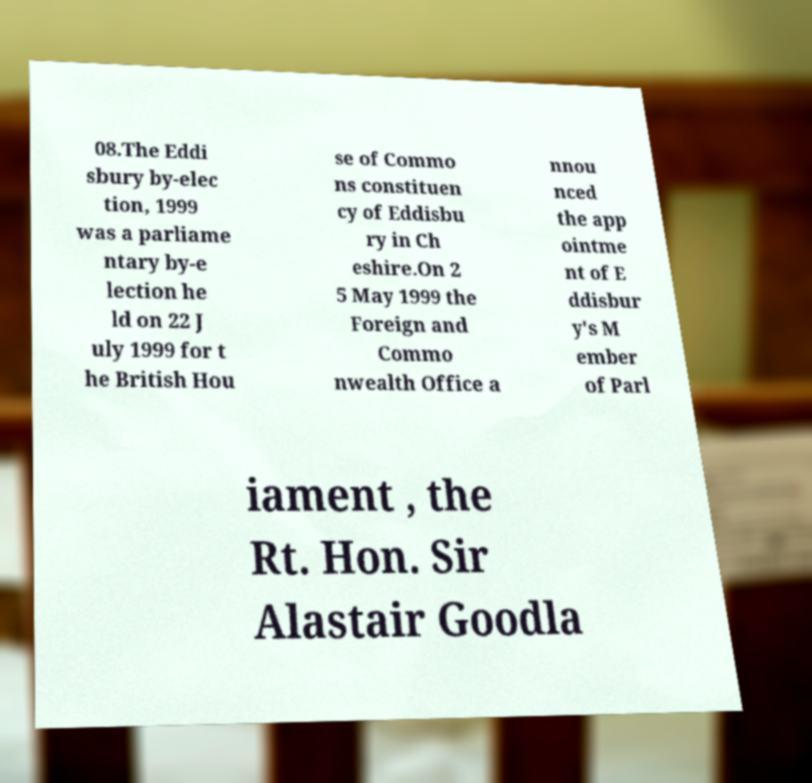Please identify and transcribe the text found in this image. 08.The Eddi sbury by-elec tion, 1999 was a parliame ntary by-e lection he ld on 22 J uly 1999 for t he British Hou se of Commo ns constituen cy of Eddisbu ry in Ch eshire.On 2 5 May 1999 the Foreign and Commo nwealth Office a nnou nced the app ointme nt of E ddisbur y's M ember of Parl iament , the Rt. Hon. Sir Alastair Goodla 